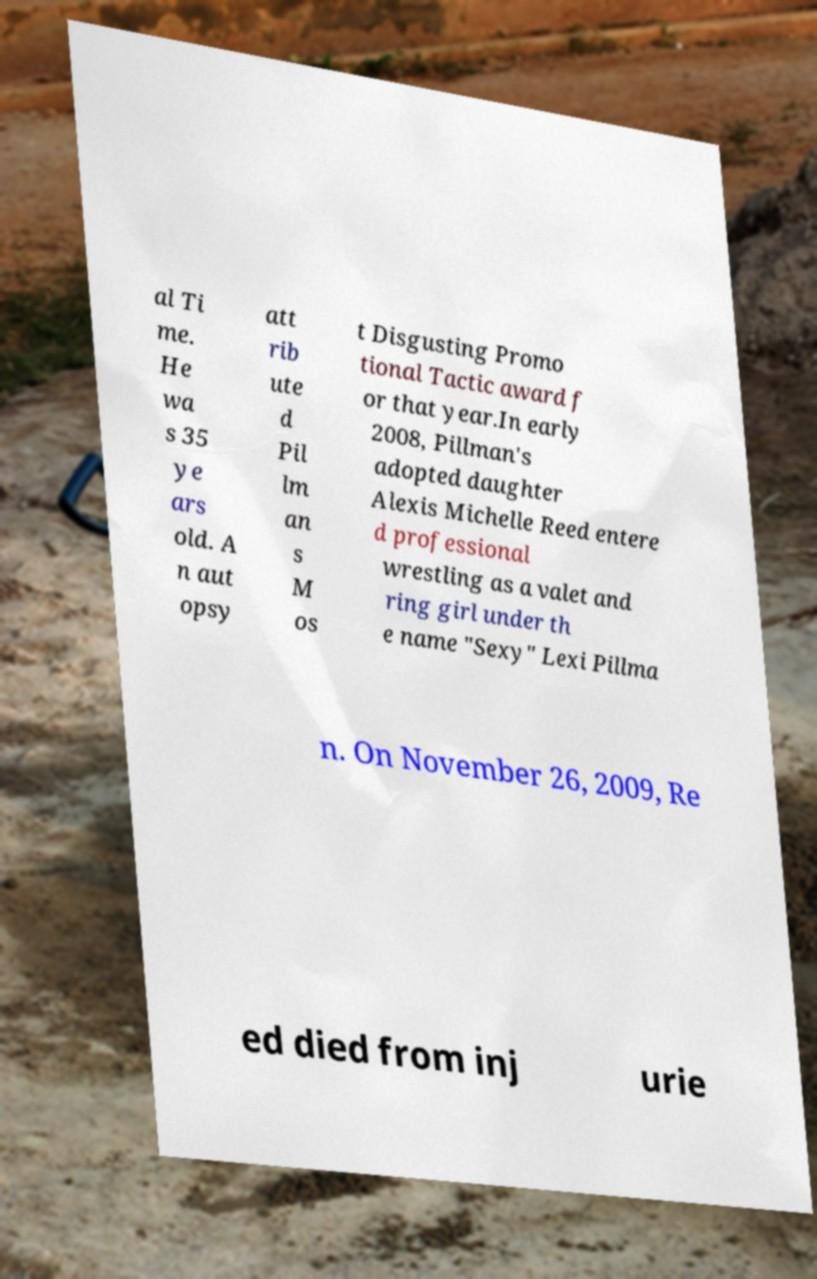Can you accurately transcribe the text from the provided image for me? al Ti me. He wa s 35 ye ars old. A n aut opsy att rib ute d Pil lm an s M os t Disgusting Promo tional Tactic award f or that year.In early 2008, Pillman's adopted daughter Alexis Michelle Reed entere d professional wrestling as a valet and ring girl under th e name "Sexy" Lexi Pillma n. On November 26, 2009, Re ed died from inj urie 